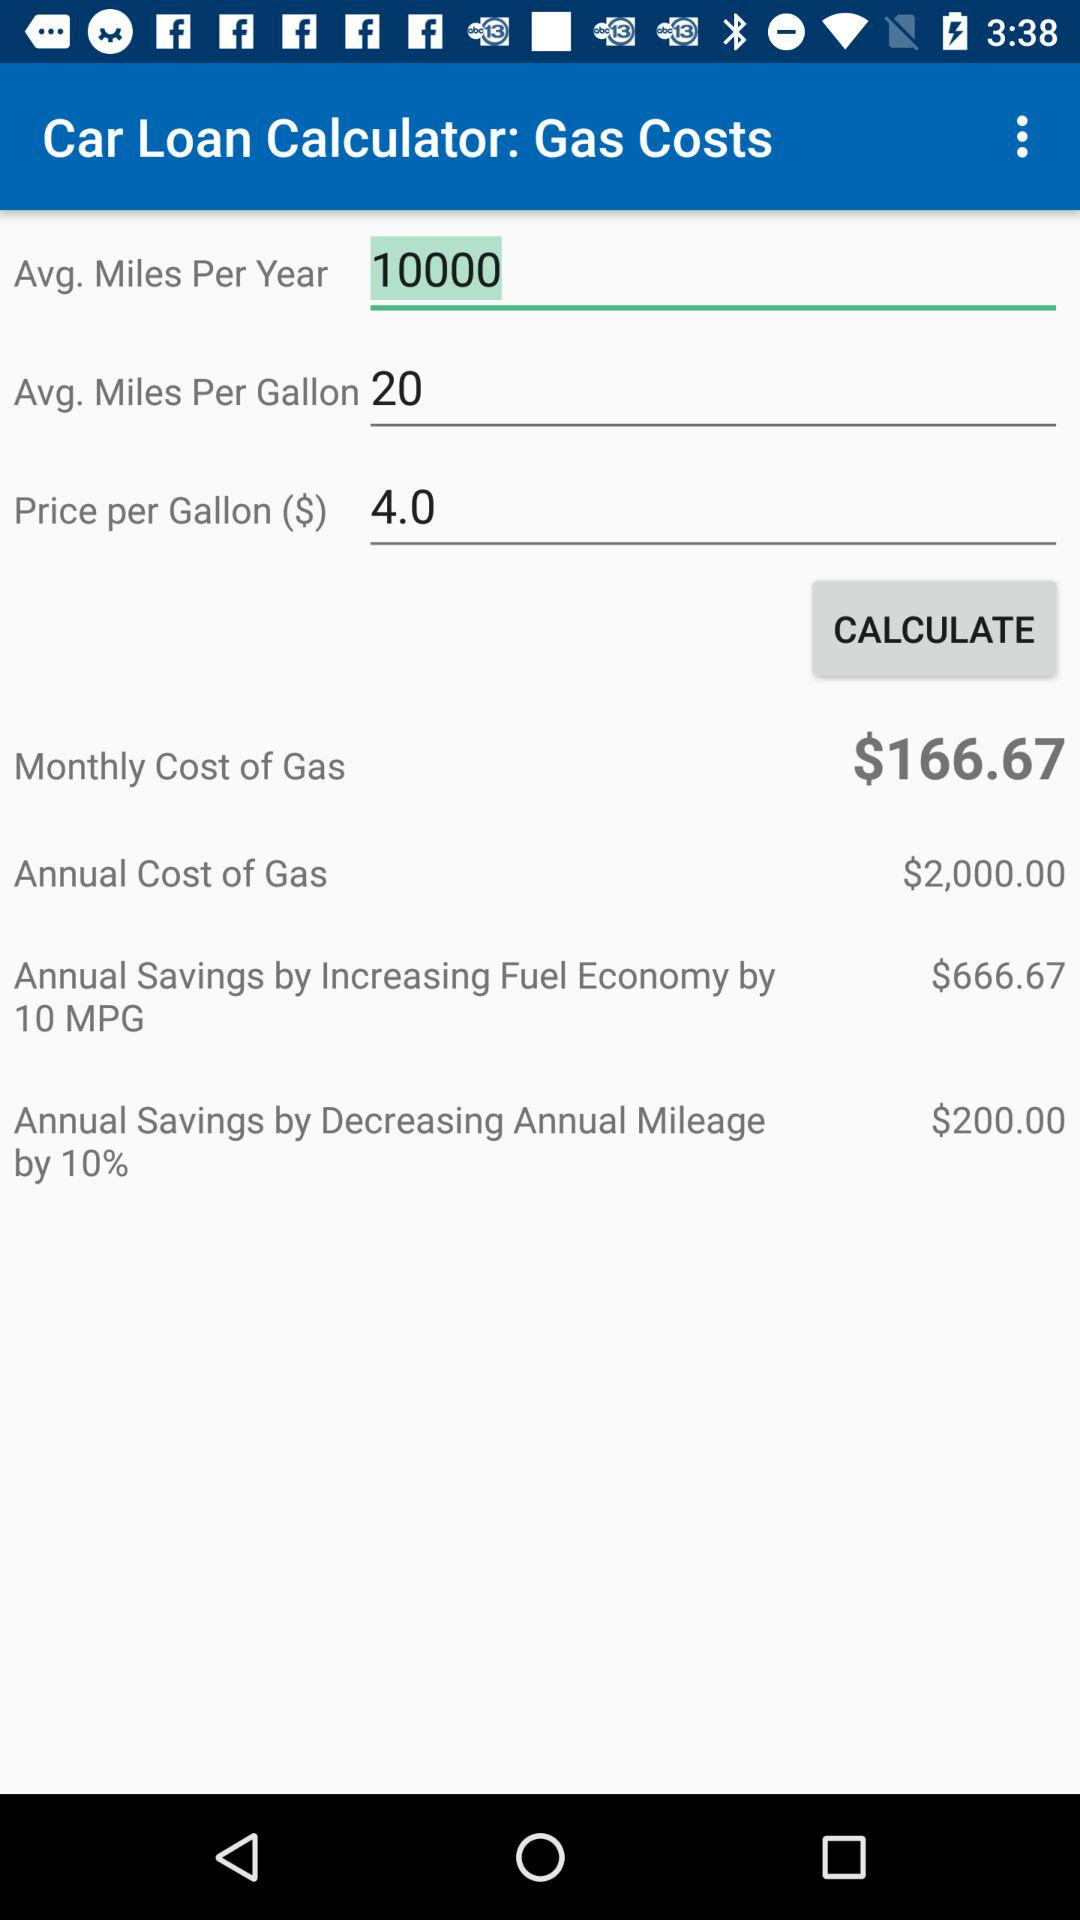What is the monthly cost of gas? The monthly cost of gas is $166.67. 